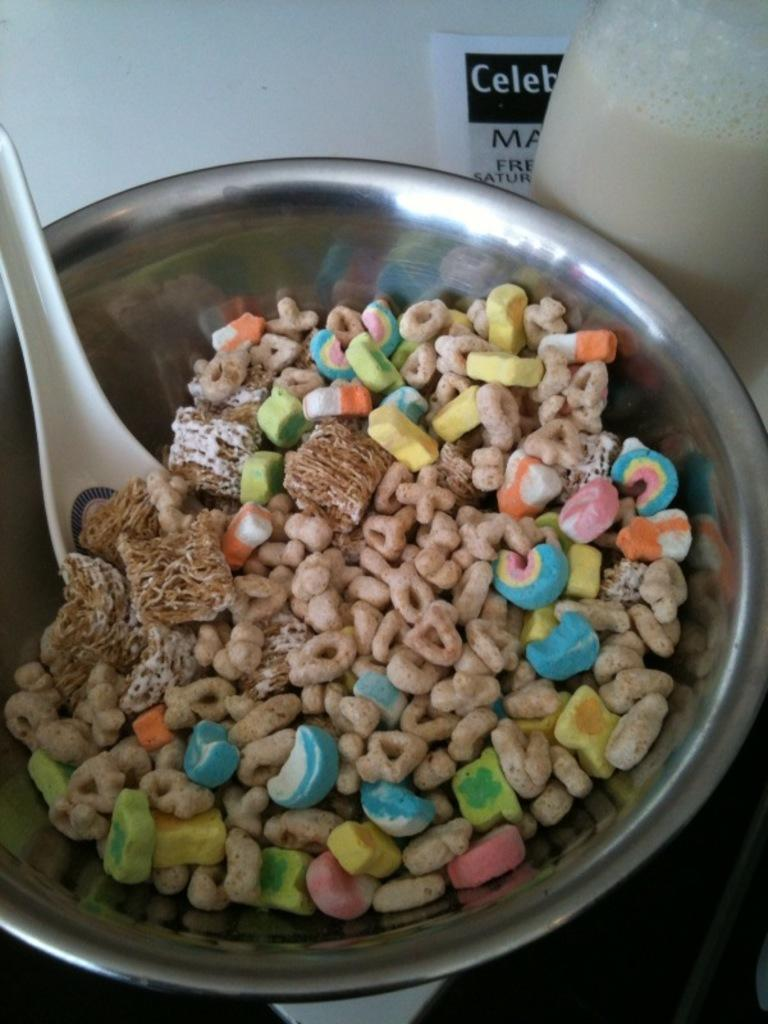What is the main subject of the image? The main subject of the image is food served in a bowl. What utensil is visible in the image? There is a spoon visible in the image. How many fish can be seen swimming in the bowl in the image? There are no fish present in the image; it features food served in a bowl. What type of lumber is being used to support the bowl in the image? There is no lumber visible in the image; it only shows a bowl of food and a spoon. 